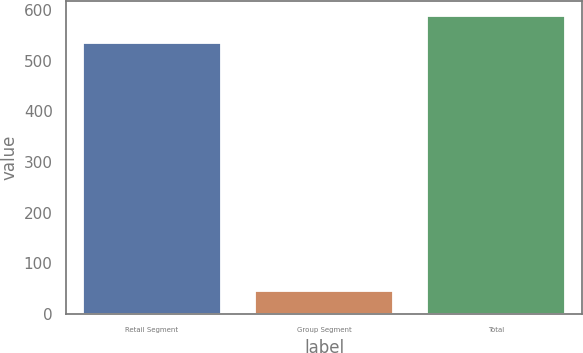Convert chart to OTSL. <chart><loc_0><loc_0><loc_500><loc_500><bar_chart><fcel>Retail Segment<fcel>Group Segment<fcel>Total<nl><fcel>535<fcel>46<fcel>588.6<nl></chart> 